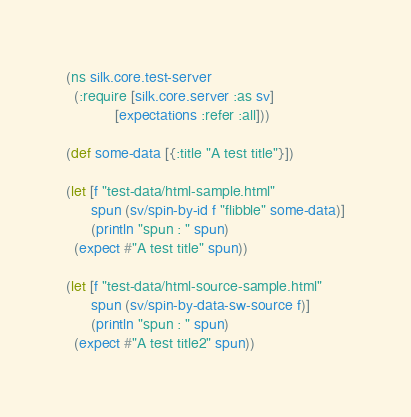<code> <loc_0><loc_0><loc_500><loc_500><_Clojure_>(ns silk.core.test-server
  (:require [silk.core.server :as sv]
            [expectations :refer :all]))

(def some-data [{:title "A test title"}])

(let [f "test-data/html-sample.html"
      spun (sv/spin-by-id f "flibble" some-data)]
      (println "spun : " spun)
  (expect #"A test title" spun))

(let [f "test-data/html-source-sample.html"
      spun (sv/spin-by-data-sw-source f)]
      (println "spun : " spun)
  (expect #"A test title2" spun))
</code> 